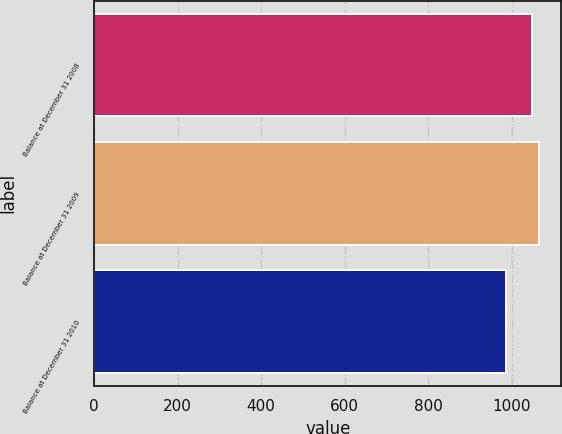Convert chart. <chart><loc_0><loc_0><loc_500><loc_500><bar_chart><fcel>Balance at December 31 2008<fcel>Balance at December 31 2009<fcel>Balance at December 31 2010<nl><fcel>1048.3<fcel>1065.9<fcel>985.6<nl></chart> 